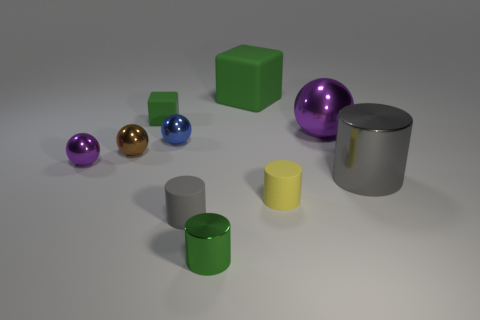Subtract all blue cylinders. How many purple spheres are left? 2 Subtract all small purple balls. How many balls are left? 3 Subtract 1 spheres. How many spheres are left? 3 Subtract all brown spheres. How many spheres are left? 3 Subtract all blocks. How many objects are left? 8 Subtract all cyan balls. Subtract all cyan cylinders. How many balls are left? 4 Subtract all tiny green blocks. Subtract all blue things. How many objects are left? 8 Add 8 green shiny cylinders. How many green shiny cylinders are left? 9 Add 1 small blue balls. How many small blue balls exist? 2 Subtract 2 gray cylinders. How many objects are left? 8 